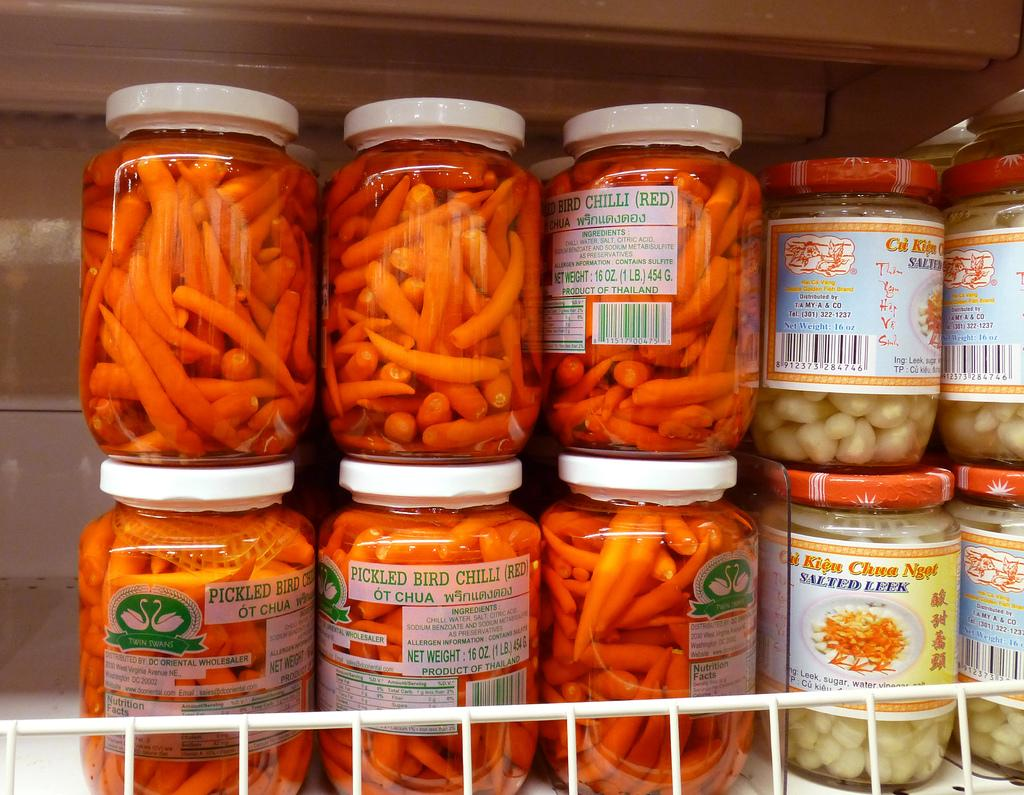What is the main object in the image? There is a bottle rack in the image. What is placed on the bottle rack? There are bottles in the rack. What is inside the bottles? The bottles contain a food item. What type of horn can be heard coming from the bottles in the image? There is no horn or sound coming from the bottles in the image; they contain a food item. 